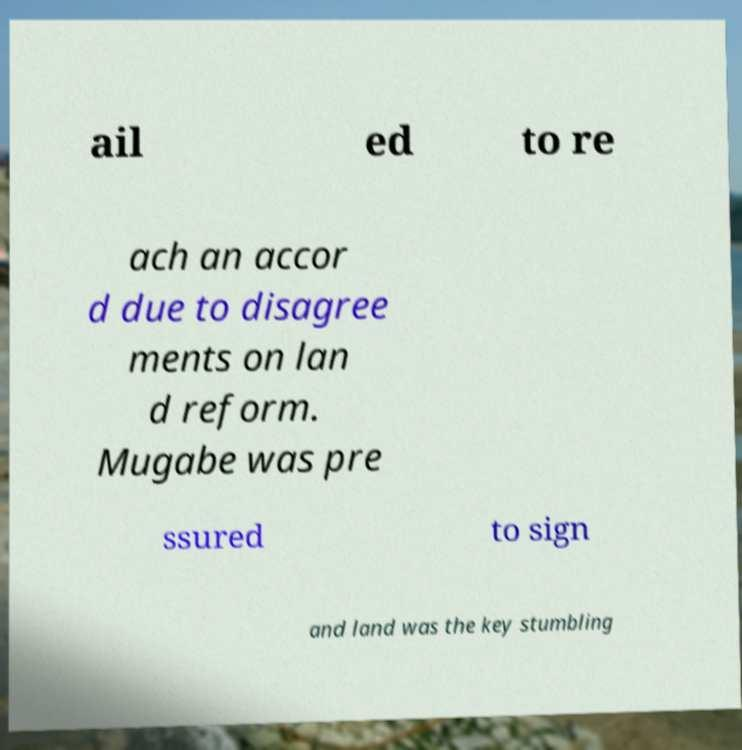What messages or text are displayed in this image? I need them in a readable, typed format. ail ed to re ach an accor d due to disagree ments on lan d reform. Mugabe was pre ssured to sign and land was the key stumbling 